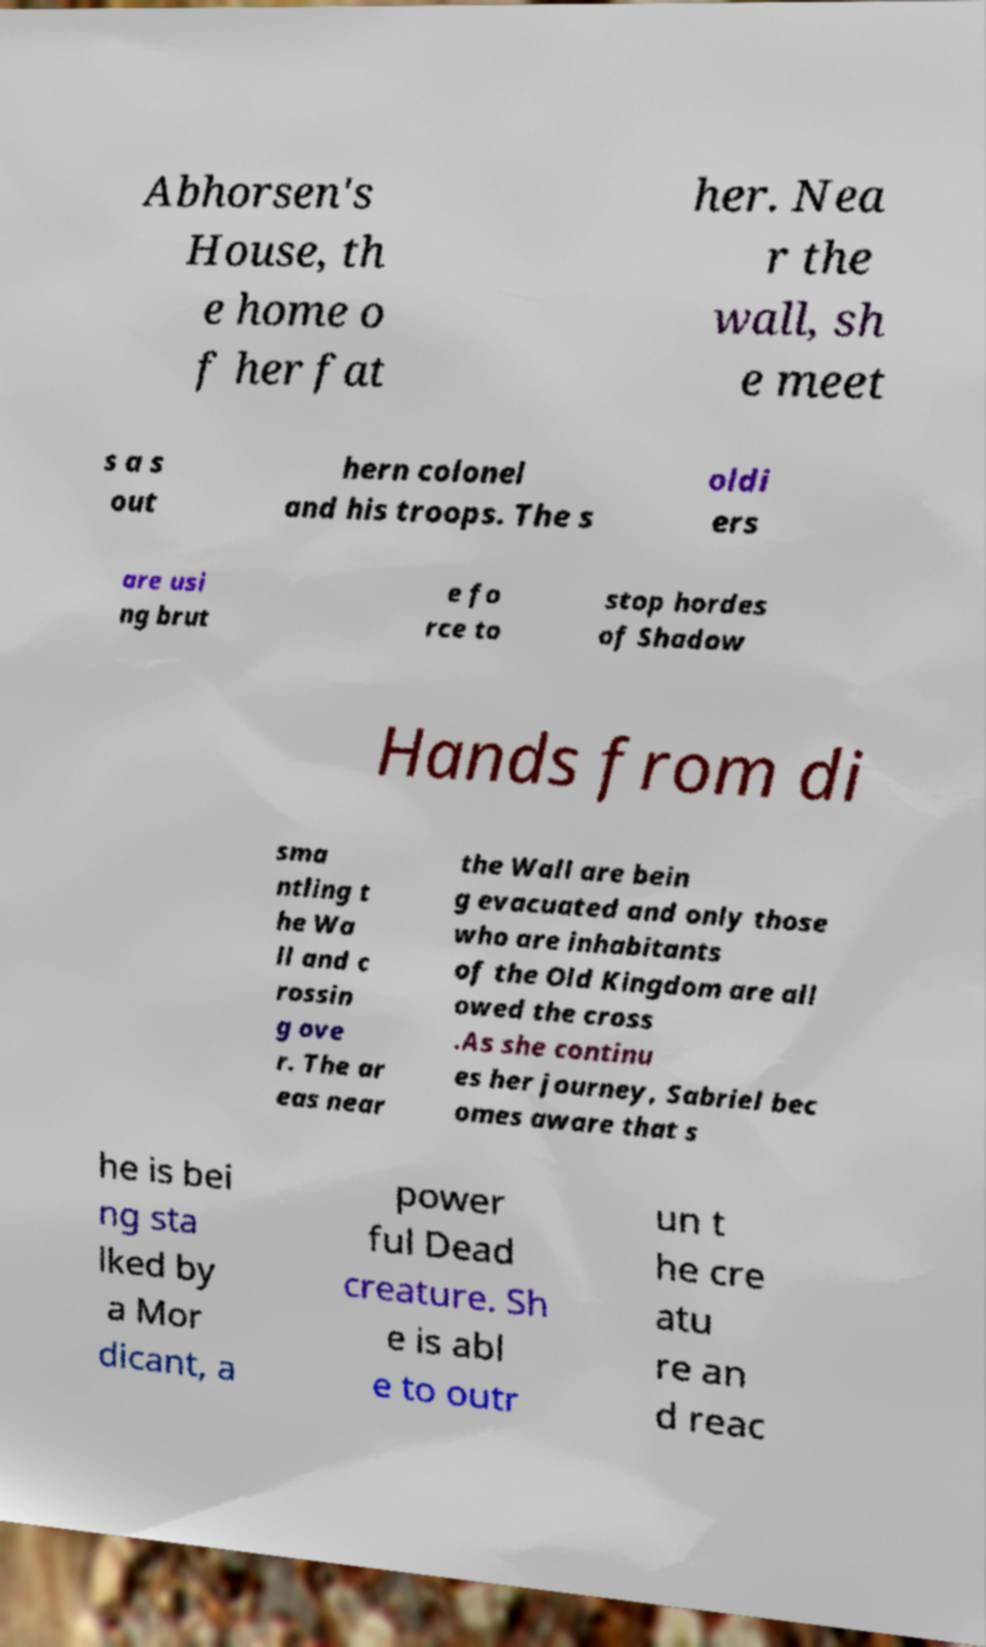Please read and relay the text visible in this image. What does it say? Abhorsen's House, th e home o f her fat her. Nea r the wall, sh e meet s a s out hern colonel and his troops. The s oldi ers are usi ng brut e fo rce to stop hordes of Shadow Hands from di sma ntling t he Wa ll and c rossin g ove r. The ar eas near the Wall are bein g evacuated and only those who are inhabitants of the Old Kingdom are all owed the cross .As she continu es her journey, Sabriel bec omes aware that s he is bei ng sta lked by a Mor dicant, a power ful Dead creature. Sh e is abl e to outr un t he cre atu re an d reac 